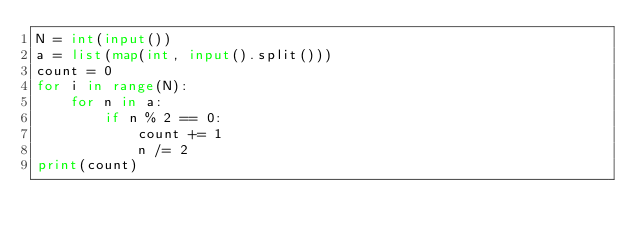<code> <loc_0><loc_0><loc_500><loc_500><_Python_>N = int(input())
a = list(map(int, input().split()))
count = 0
for i in range(N):
	for n in a:
 		if n % 2 == 0:
    		count += 1
            n /= 2
print(count)</code> 